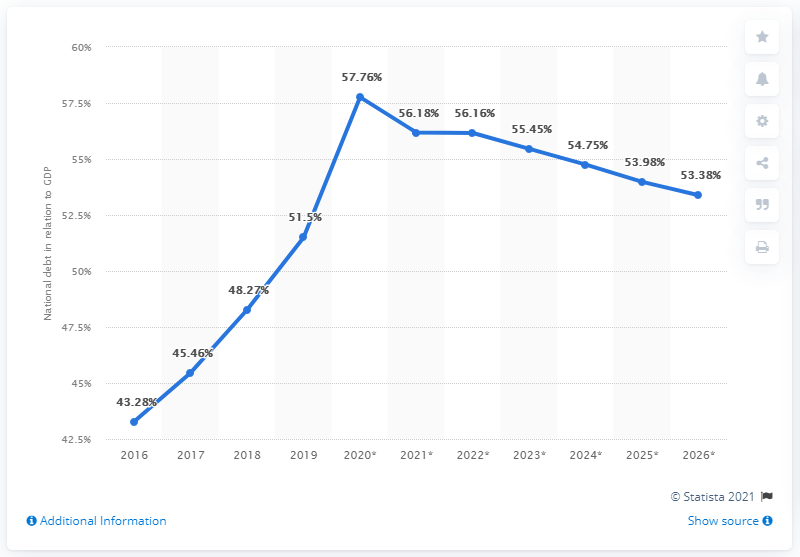Outline some significant characteristics in this image. The national debt of Sub-Saharan Africa in 2019 was 51.5. 